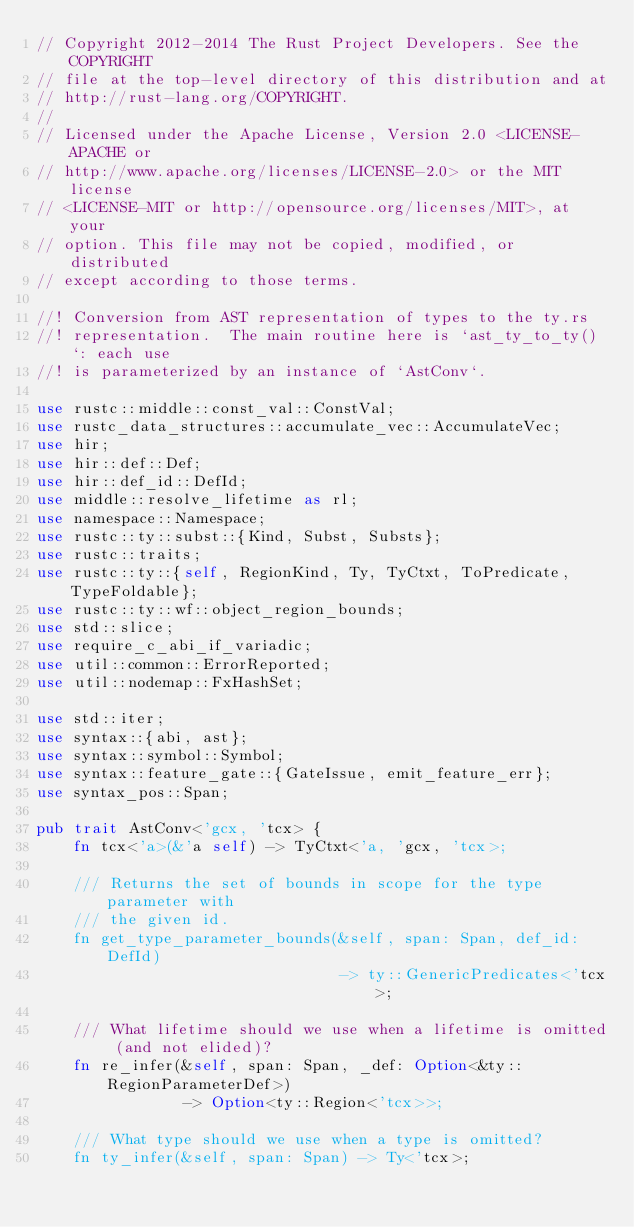<code> <loc_0><loc_0><loc_500><loc_500><_Rust_>// Copyright 2012-2014 The Rust Project Developers. See the COPYRIGHT
// file at the top-level directory of this distribution and at
// http://rust-lang.org/COPYRIGHT.
//
// Licensed under the Apache License, Version 2.0 <LICENSE-APACHE or
// http://www.apache.org/licenses/LICENSE-2.0> or the MIT license
// <LICENSE-MIT or http://opensource.org/licenses/MIT>, at your
// option. This file may not be copied, modified, or distributed
// except according to those terms.

//! Conversion from AST representation of types to the ty.rs
//! representation.  The main routine here is `ast_ty_to_ty()`: each use
//! is parameterized by an instance of `AstConv`.

use rustc::middle::const_val::ConstVal;
use rustc_data_structures::accumulate_vec::AccumulateVec;
use hir;
use hir::def::Def;
use hir::def_id::DefId;
use middle::resolve_lifetime as rl;
use namespace::Namespace;
use rustc::ty::subst::{Kind, Subst, Substs};
use rustc::traits;
use rustc::ty::{self, RegionKind, Ty, TyCtxt, ToPredicate, TypeFoldable};
use rustc::ty::wf::object_region_bounds;
use std::slice;
use require_c_abi_if_variadic;
use util::common::ErrorReported;
use util::nodemap::FxHashSet;

use std::iter;
use syntax::{abi, ast};
use syntax::symbol::Symbol;
use syntax::feature_gate::{GateIssue, emit_feature_err};
use syntax_pos::Span;

pub trait AstConv<'gcx, 'tcx> {
    fn tcx<'a>(&'a self) -> TyCtxt<'a, 'gcx, 'tcx>;

    /// Returns the set of bounds in scope for the type parameter with
    /// the given id.
    fn get_type_parameter_bounds(&self, span: Span, def_id: DefId)
                                 -> ty::GenericPredicates<'tcx>;

    /// What lifetime should we use when a lifetime is omitted (and not elided)?
    fn re_infer(&self, span: Span, _def: Option<&ty::RegionParameterDef>)
                -> Option<ty::Region<'tcx>>;

    /// What type should we use when a type is omitted?
    fn ty_infer(&self, span: Span) -> Ty<'tcx>;
</code> 